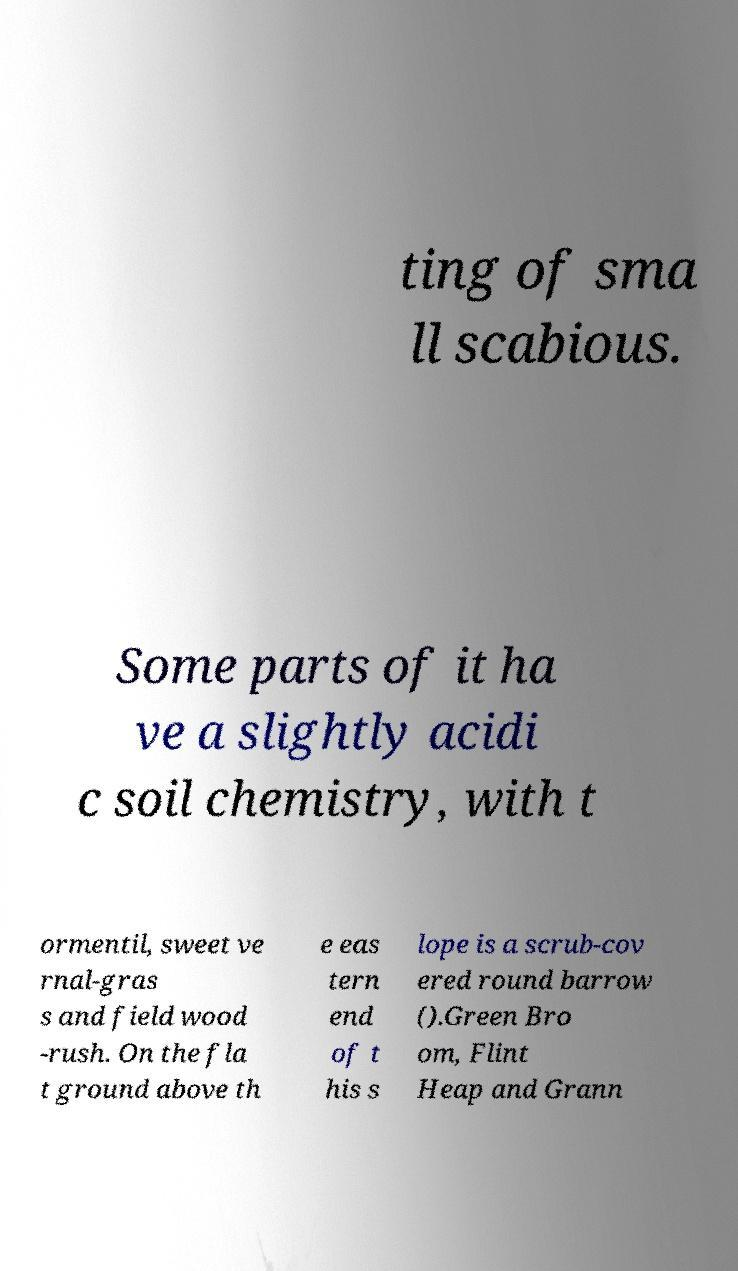Can you accurately transcribe the text from the provided image for me? ting of sma ll scabious. Some parts of it ha ve a slightly acidi c soil chemistry, with t ormentil, sweet ve rnal-gras s and field wood -rush. On the fla t ground above th e eas tern end of t his s lope is a scrub-cov ered round barrow ().Green Bro om, Flint Heap and Grann 